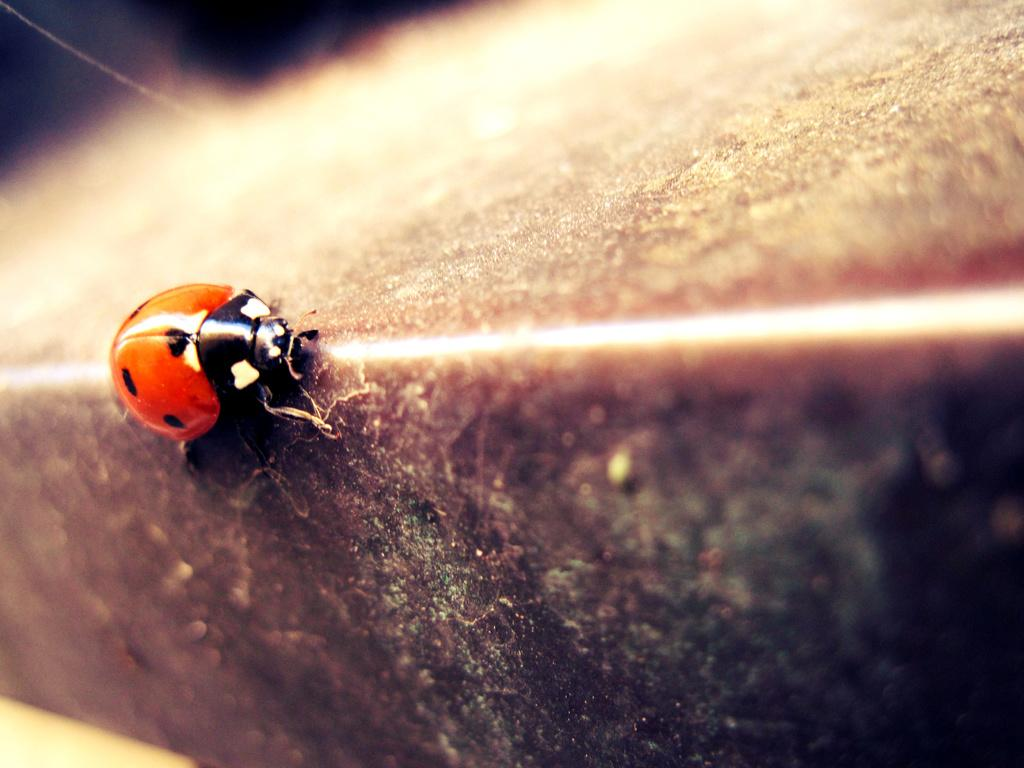What type of creature can be seen in the image? There is an insect in the image. Where is the insect located in the image? The insect is on a surface. What type of straw is the insect using to communicate in the image? There is no straw present in the image, and insects do not communicate using straws. 